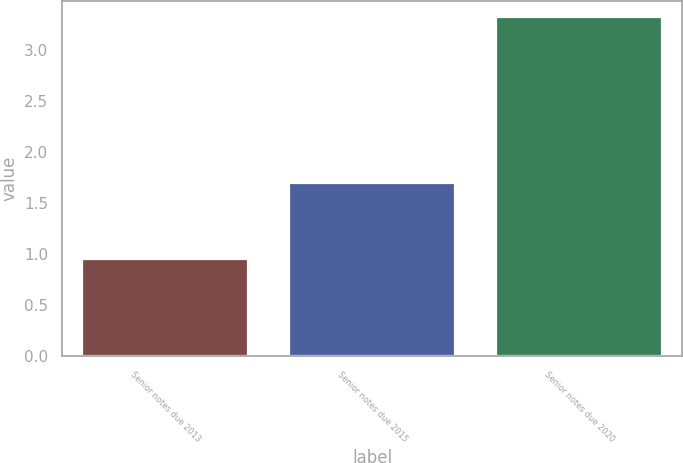<chart> <loc_0><loc_0><loc_500><loc_500><bar_chart><fcel>Senior notes due 2013<fcel>Senior notes due 2015<fcel>Senior notes due 2020<nl><fcel>0.95<fcel>1.7<fcel>3.32<nl></chart> 